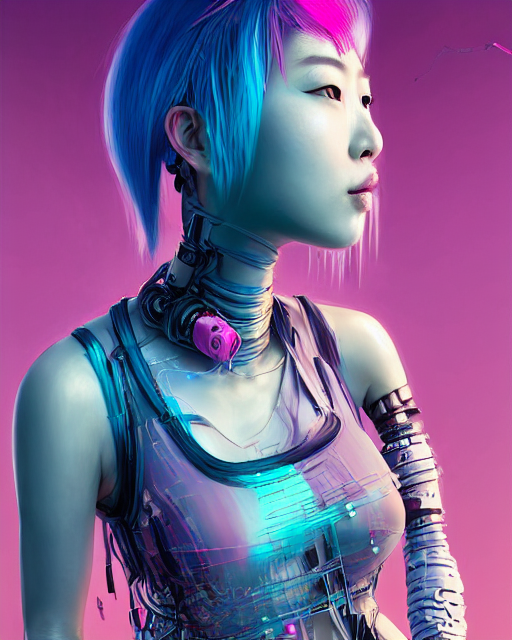Is there distortion in the robot's clothes?
A. No
B. Yes
Answer with the option's letter from the given choices directly.
 B. 